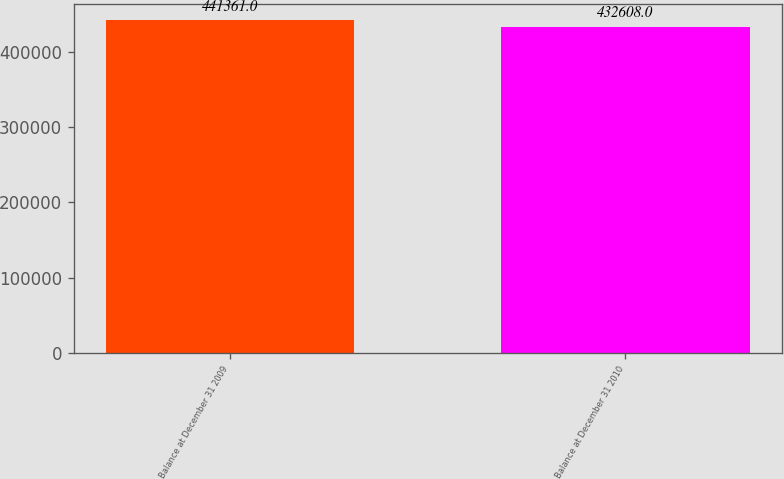Convert chart to OTSL. <chart><loc_0><loc_0><loc_500><loc_500><bar_chart><fcel>Balance at December 31 2009<fcel>Balance at December 31 2010<nl><fcel>441361<fcel>432608<nl></chart> 